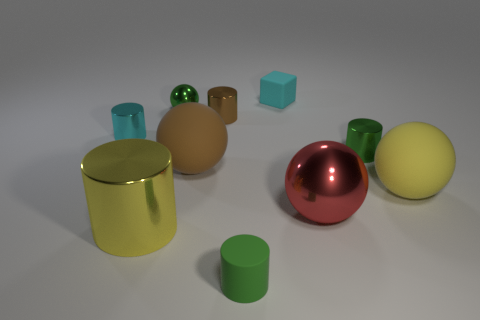The brown shiny object is what size?
Offer a terse response. Small. What is the size of the green thing that is in front of the red thing?
Provide a succinct answer. Small. There is a object that is both to the right of the cube and left of the tiny green metallic cylinder; what shape is it?
Give a very brief answer. Sphere. How many other objects are there of the same shape as the red object?
Your answer should be compact. 3. There is a metallic ball that is the same size as the brown matte ball; what color is it?
Offer a very short reply. Red. How many objects are large yellow rubber cylinders or large matte things?
Your answer should be very brief. 2. There is a big brown thing; are there any big cylinders behind it?
Your answer should be very brief. No. Are there any cubes made of the same material as the large brown sphere?
Offer a very short reply. Yes. What is the size of the ball that is the same color as the small rubber cylinder?
Give a very brief answer. Small. What number of cylinders are either yellow metallic things or big yellow objects?
Provide a succinct answer. 1. 